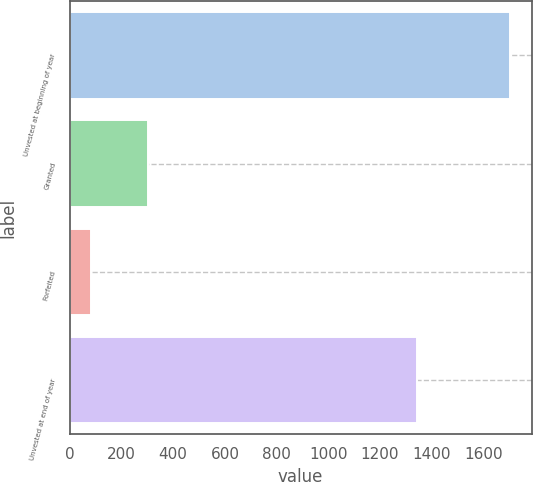Convert chart to OTSL. <chart><loc_0><loc_0><loc_500><loc_500><bar_chart><fcel>Unvested at beginning of year<fcel>Granted<fcel>Forfeited<fcel>Unvested at end of year<nl><fcel>1701<fcel>304<fcel>82<fcel>1343<nl></chart> 